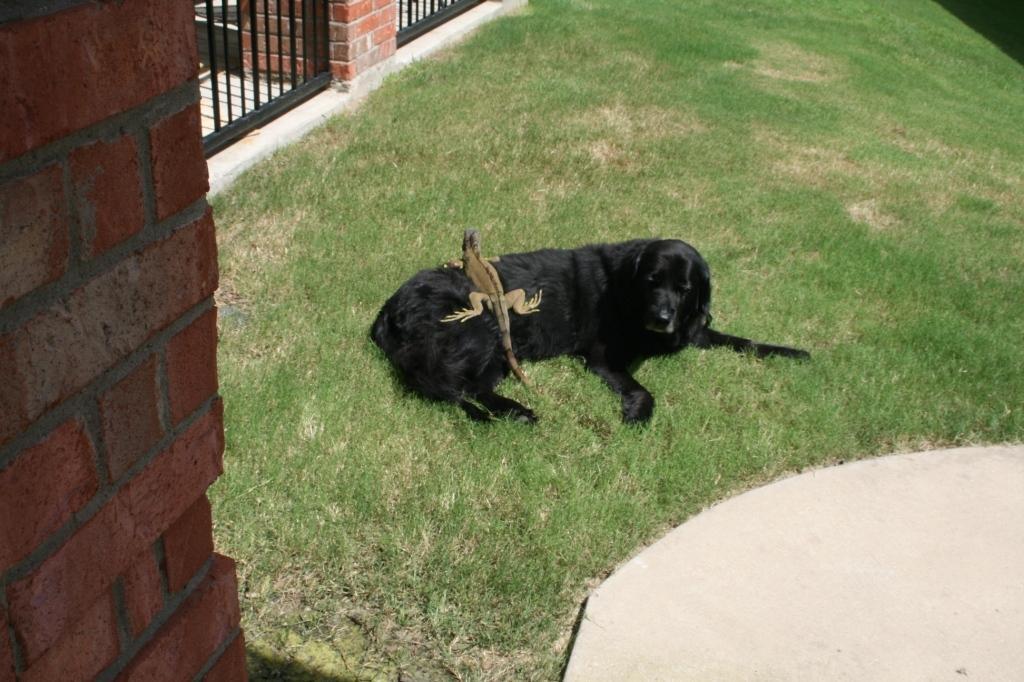In one or two sentences, can you explain what this image depicts? In this picture we can see reptile on dog and grass. On the left side of the image we can see bricks wall. In the background of the image we can see grilles and wall. 